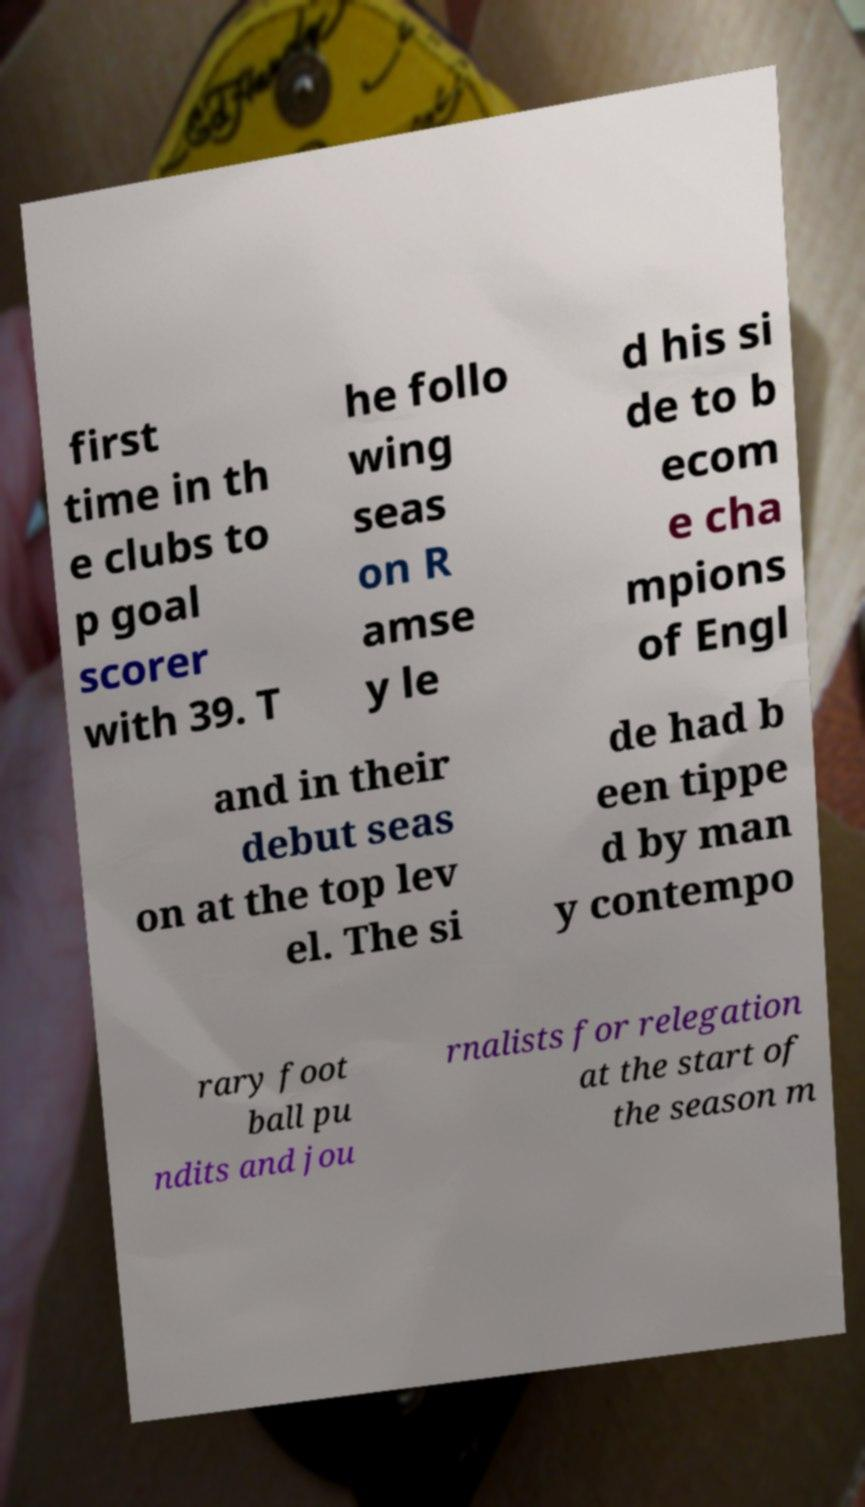Could you extract and type out the text from this image? first time in th e clubs to p goal scorer with 39. T he follo wing seas on R amse y le d his si de to b ecom e cha mpions of Engl and in their debut seas on at the top lev el. The si de had b een tippe d by man y contempo rary foot ball pu ndits and jou rnalists for relegation at the start of the season m 